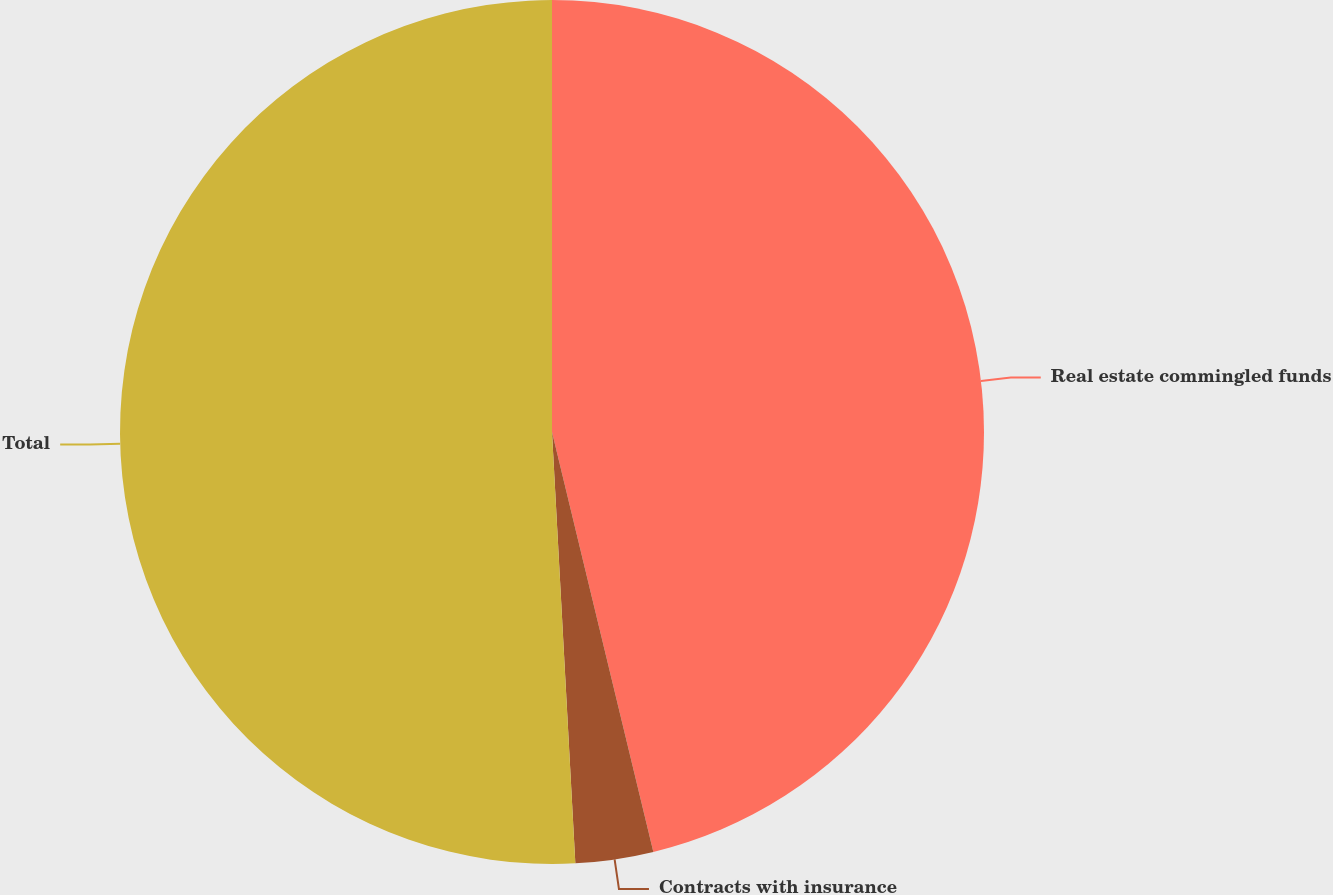Convert chart. <chart><loc_0><loc_0><loc_500><loc_500><pie_chart><fcel>Real estate commingled funds<fcel>Contracts with insurance<fcel>Total<nl><fcel>46.23%<fcel>2.91%<fcel>50.86%<nl></chart> 